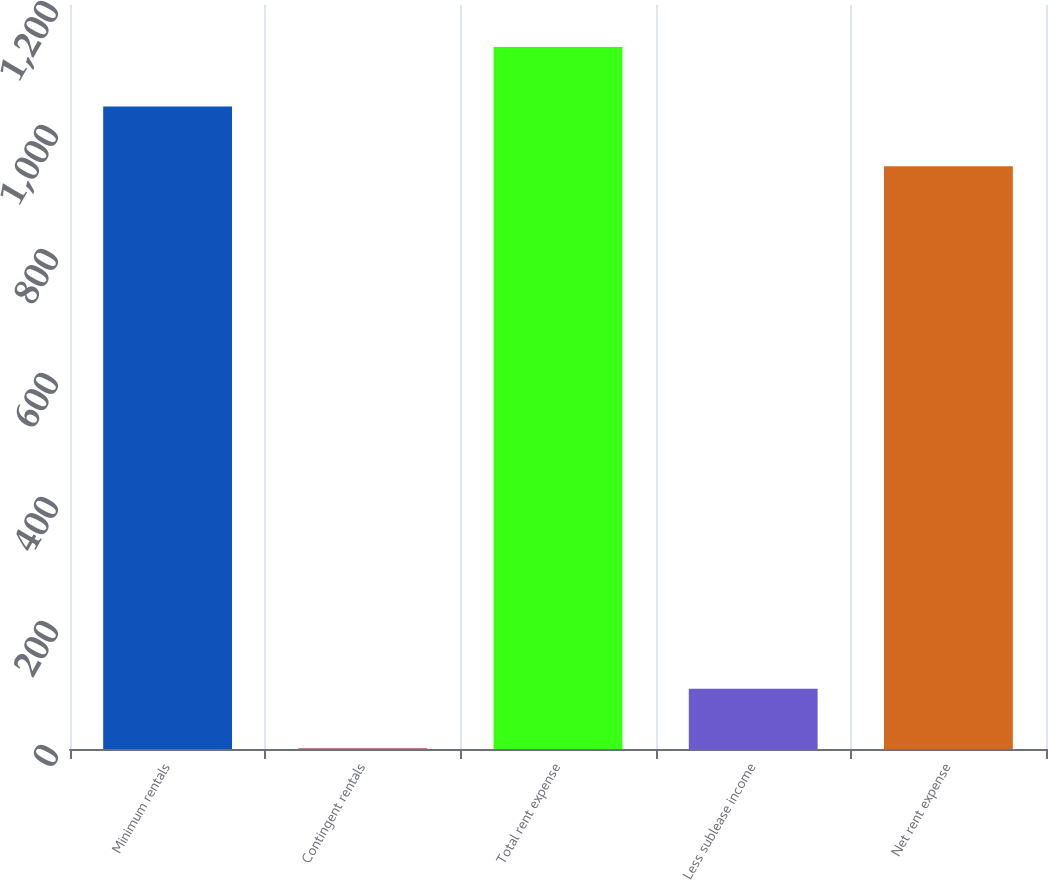Convert chart. <chart><loc_0><loc_0><loc_500><loc_500><bar_chart><fcel>Minimum rentals<fcel>Contingent rentals<fcel>Total rent expense<fcel>Less sublease income<fcel>Net rent expense<nl><fcel>1036.2<fcel>1<fcel>1132.4<fcel>97.2<fcel>940<nl></chart> 